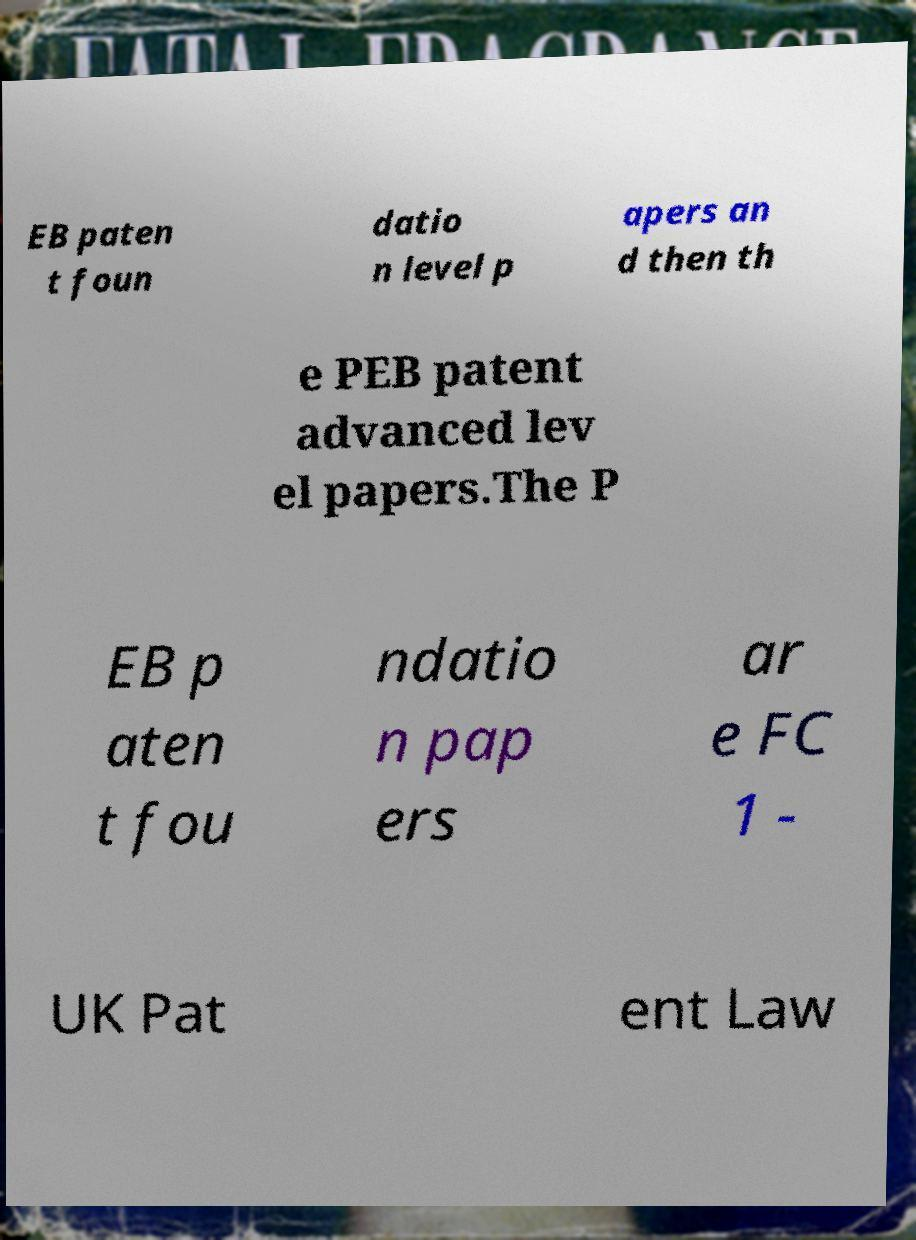Please read and relay the text visible in this image. What does it say? EB paten t foun datio n level p apers an d then th e PEB patent advanced lev el papers.The P EB p aten t fou ndatio n pap ers ar e FC 1 - UK Pat ent Law 